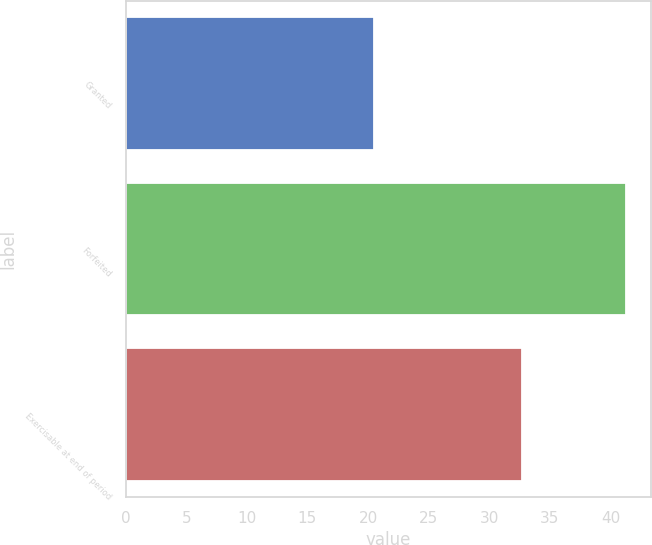Convert chart to OTSL. <chart><loc_0><loc_0><loc_500><loc_500><bar_chart><fcel>Granted<fcel>Forfeited<fcel>Exercisable at end of period<nl><fcel>20.5<fcel>41.27<fcel>32.69<nl></chart> 